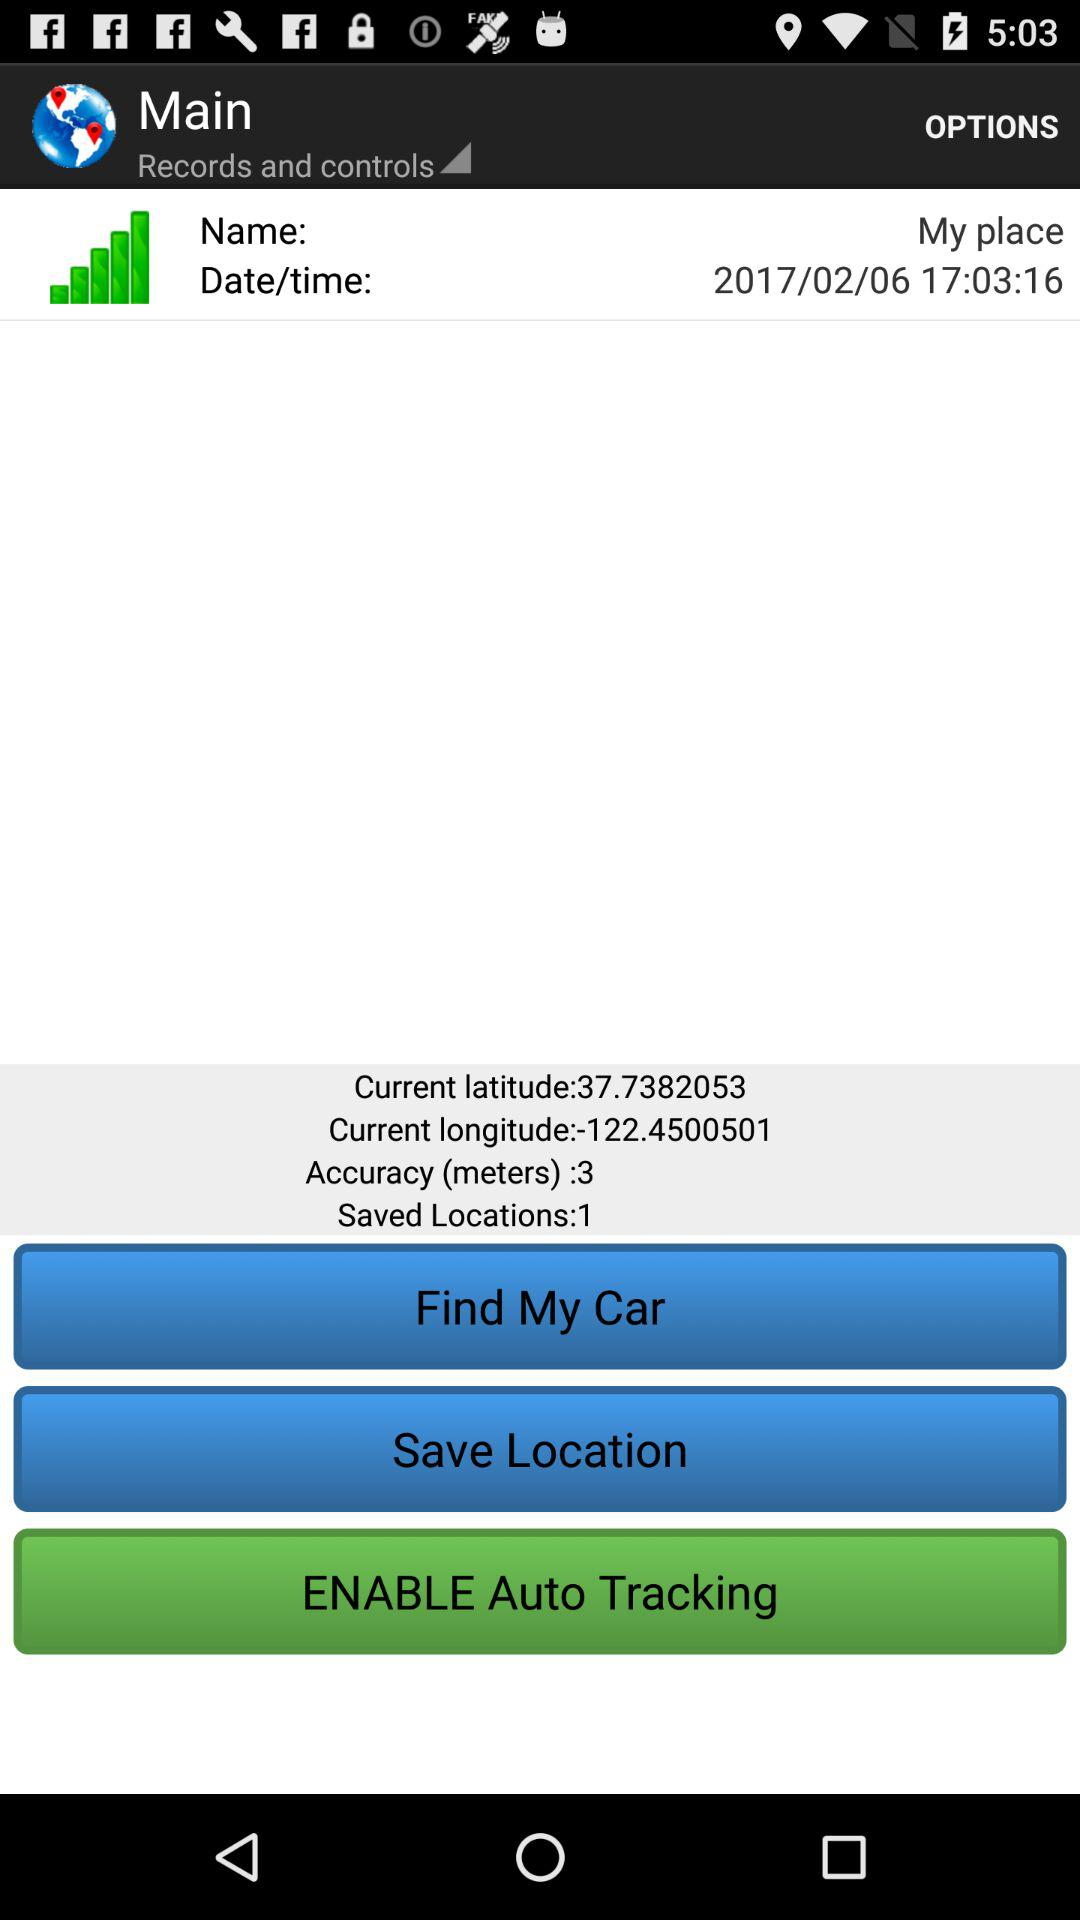How many locations are saved? There is 1 saved location. 